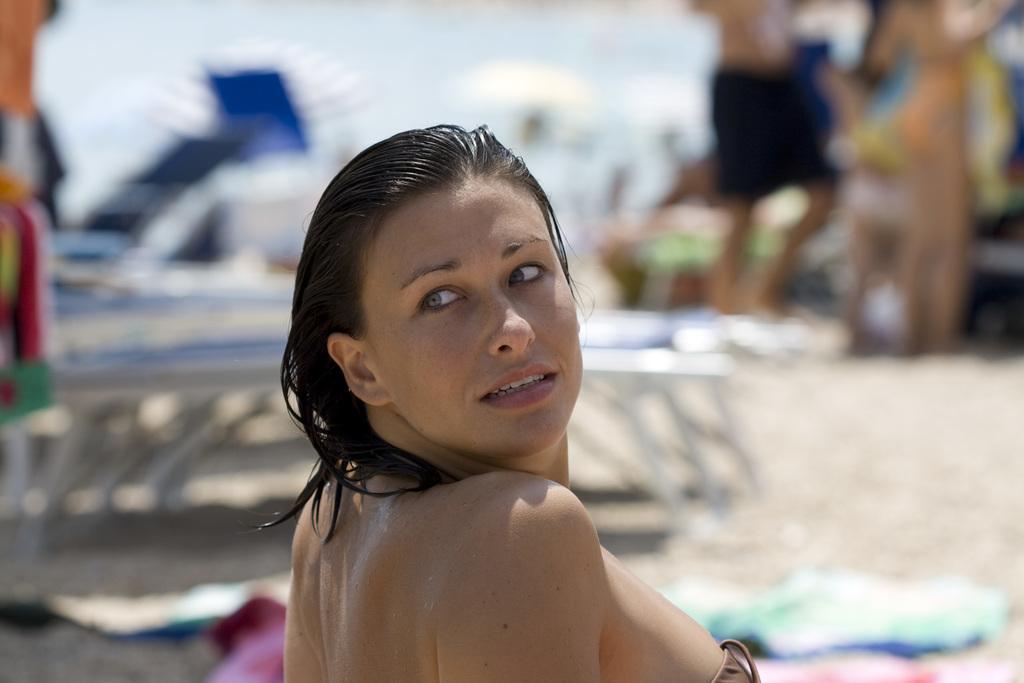Can you describe this image briefly? In front of the picture, we see a woman. She is looking at something. Behind her, we see beach beds. In the right top of the picture, we see something in green, brown and black color. In the background, it is blurred. This picture might be clicked at the beach. 